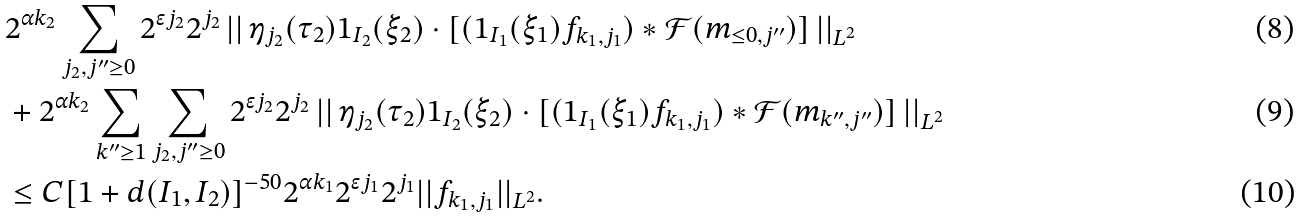Convert formula to latex. <formula><loc_0><loc_0><loc_500><loc_500>& 2 ^ { \alpha k _ { 2 } } \sum _ { j _ { 2 } , j ^ { \prime \prime } \geq 0 } 2 ^ { \epsilon j _ { 2 } } 2 ^ { j _ { 2 } } \left | \right | \eta _ { j _ { 2 } } ( \tau _ { 2 } ) 1 _ { I _ { 2 } } ( \xi _ { 2 } ) \cdot [ ( 1 _ { I _ { 1 } } ( \xi _ { 1 } ) f _ { k _ { 1 } , j _ { 1 } } ) \ast \mathcal { F } ( m _ { \leq 0 , j ^ { \prime \prime } } ) ] \left | \right | _ { L ^ { 2 } } \\ & + 2 ^ { \alpha k _ { 2 } } \sum _ { k ^ { \prime \prime } \geq 1 } \sum _ { j _ { 2 } , j ^ { \prime \prime } \geq 0 } 2 ^ { \epsilon j _ { 2 } } 2 ^ { j _ { 2 } } \left | \right | \eta _ { j _ { 2 } } ( \tau _ { 2 } ) 1 _ { I _ { 2 } } ( \xi _ { 2 } ) \cdot [ ( 1 _ { I _ { 1 } } ( \xi _ { 1 } ) f _ { k _ { 1 } , j _ { 1 } } ) \ast \mathcal { F } ( m _ { k ^ { \prime \prime } , j ^ { \prime \prime } } ) ] \left | \right | _ { L ^ { 2 } } \\ & \leq C [ 1 + d ( I _ { 1 } , I _ { 2 } ) ] ^ { - 5 0 } 2 ^ { \alpha k _ { 1 } } 2 ^ { \epsilon j _ { 1 } } 2 ^ { j _ { 1 } } | | f _ { k _ { 1 } , j _ { 1 } } | | _ { L ^ { 2 } } .</formula> 